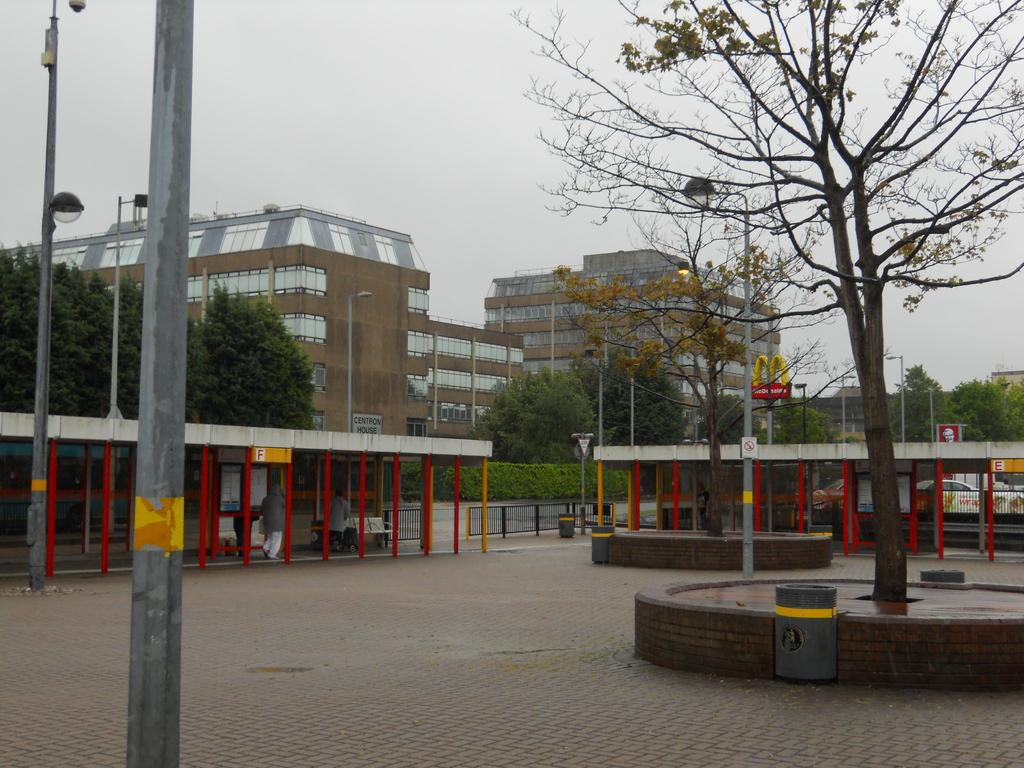What is located in the foreground of the image? There is a pole and a tree in the foreground of the image. What object is near the pole in the image? It appears to be a trash bin near the pole. What can be seen in the background of the image? There are trees, poles, buildings, sheds, and the sky visible in the background of the image. How much money is being exchanged in the image? There is no exchange of money depicted in the image. How long does it take for the minute hand to move in the image? There is no clock or timepiece present in the image, so it is not possible to determine the movement of a minute hand. 